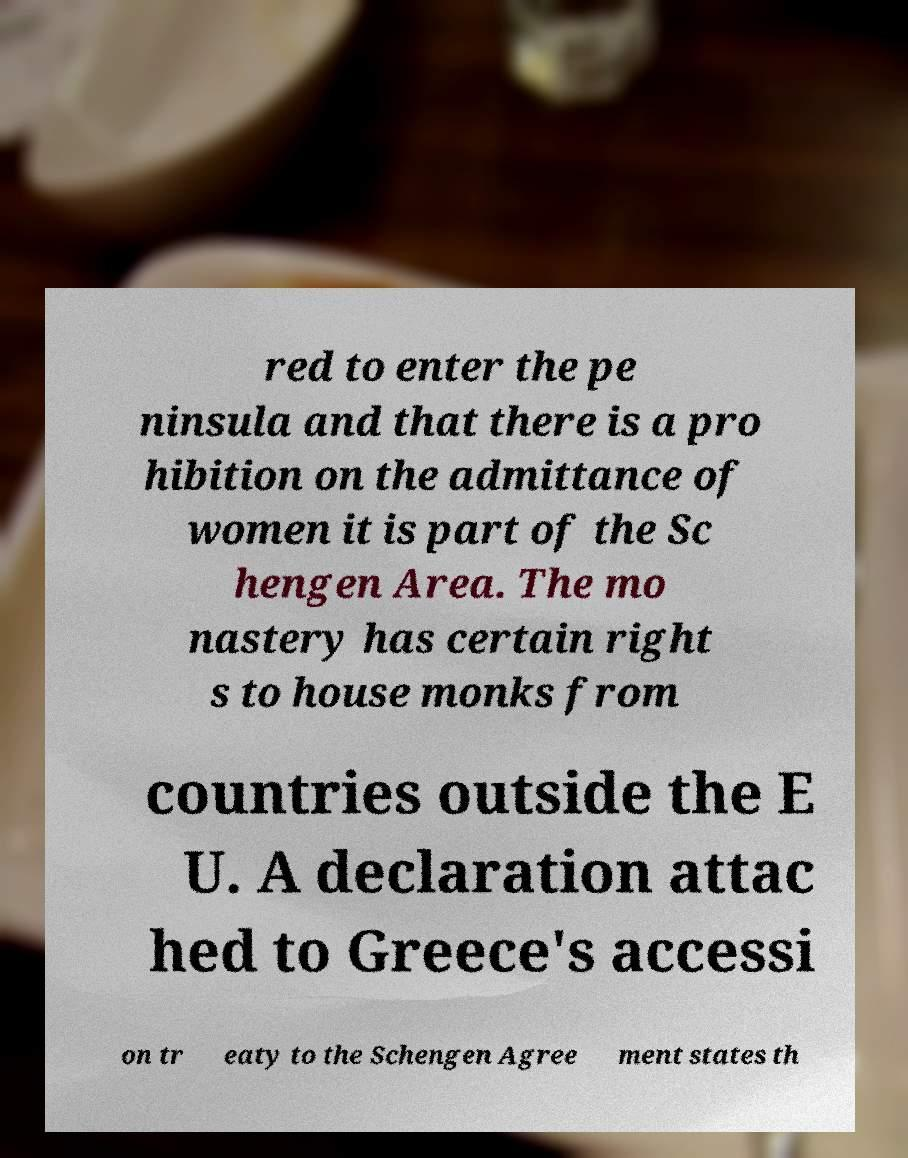Can you accurately transcribe the text from the provided image for me? red to enter the pe ninsula and that there is a pro hibition on the admittance of women it is part of the Sc hengen Area. The mo nastery has certain right s to house monks from countries outside the E U. A declaration attac hed to Greece's accessi on tr eaty to the Schengen Agree ment states th 